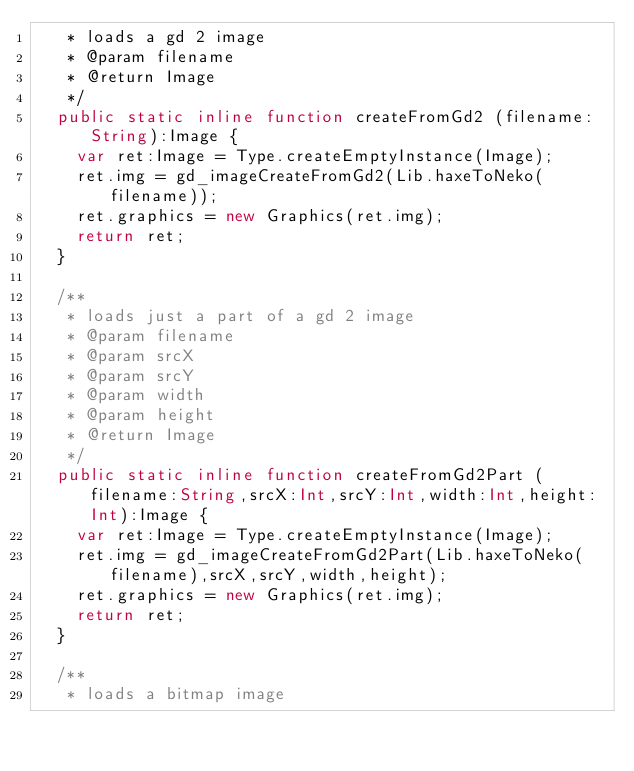<code> <loc_0><loc_0><loc_500><loc_500><_Haxe_>	 * loads a gd 2 image
	 * @param	filename
	 * @return Image
	 */
	public static inline function createFromGd2 (filename:String):Image {
		var ret:Image = Type.createEmptyInstance(Image);
		ret.img = gd_imageCreateFromGd2(Lib.haxeToNeko(filename));
		ret.graphics = new Graphics(ret.img);
		return ret;
	}
	
	/**
	 * loads just a part of a gd 2 image
	 * @param	filename
	 * @param	srcX
	 * @param	srcY
	 * @param	width
	 * @param	height
	 * @return Image
	 */
	public static inline function createFromGd2Part (filename:String,srcX:Int,srcY:Int,width:Int,height:Int):Image {
		var ret:Image = Type.createEmptyInstance(Image);
		ret.img = gd_imageCreateFromGd2Part(Lib.haxeToNeko(filename),srcX,srcY,width,height);
		ret.graphics = new Graphics(ret.img);
		return ret;
	}
	
	/**
	 * loads a bitmap image</code> 